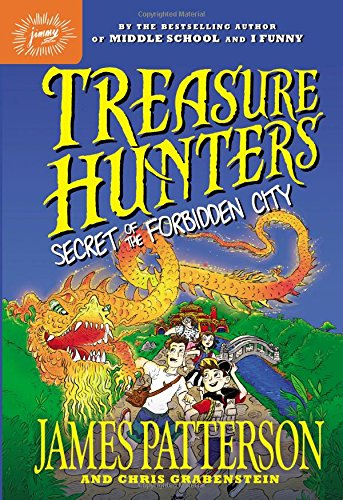What age group is this book targeted towards given its illustration style? The colorful and animated style of the book cover, coupled with a youthful group of characters, indicates that it's targeted towards middle school children, aiming to captivate young readers with its vivid storytelling and lively illustrations. Do you think this artistic approach is effective for engaging its target audience? Absolutely, the vibrant and adventurous themes conveyed through the artistic style are likely to draw in young readers, making the reading experience fun and engaging, which is crucial for developing early reading habits. 